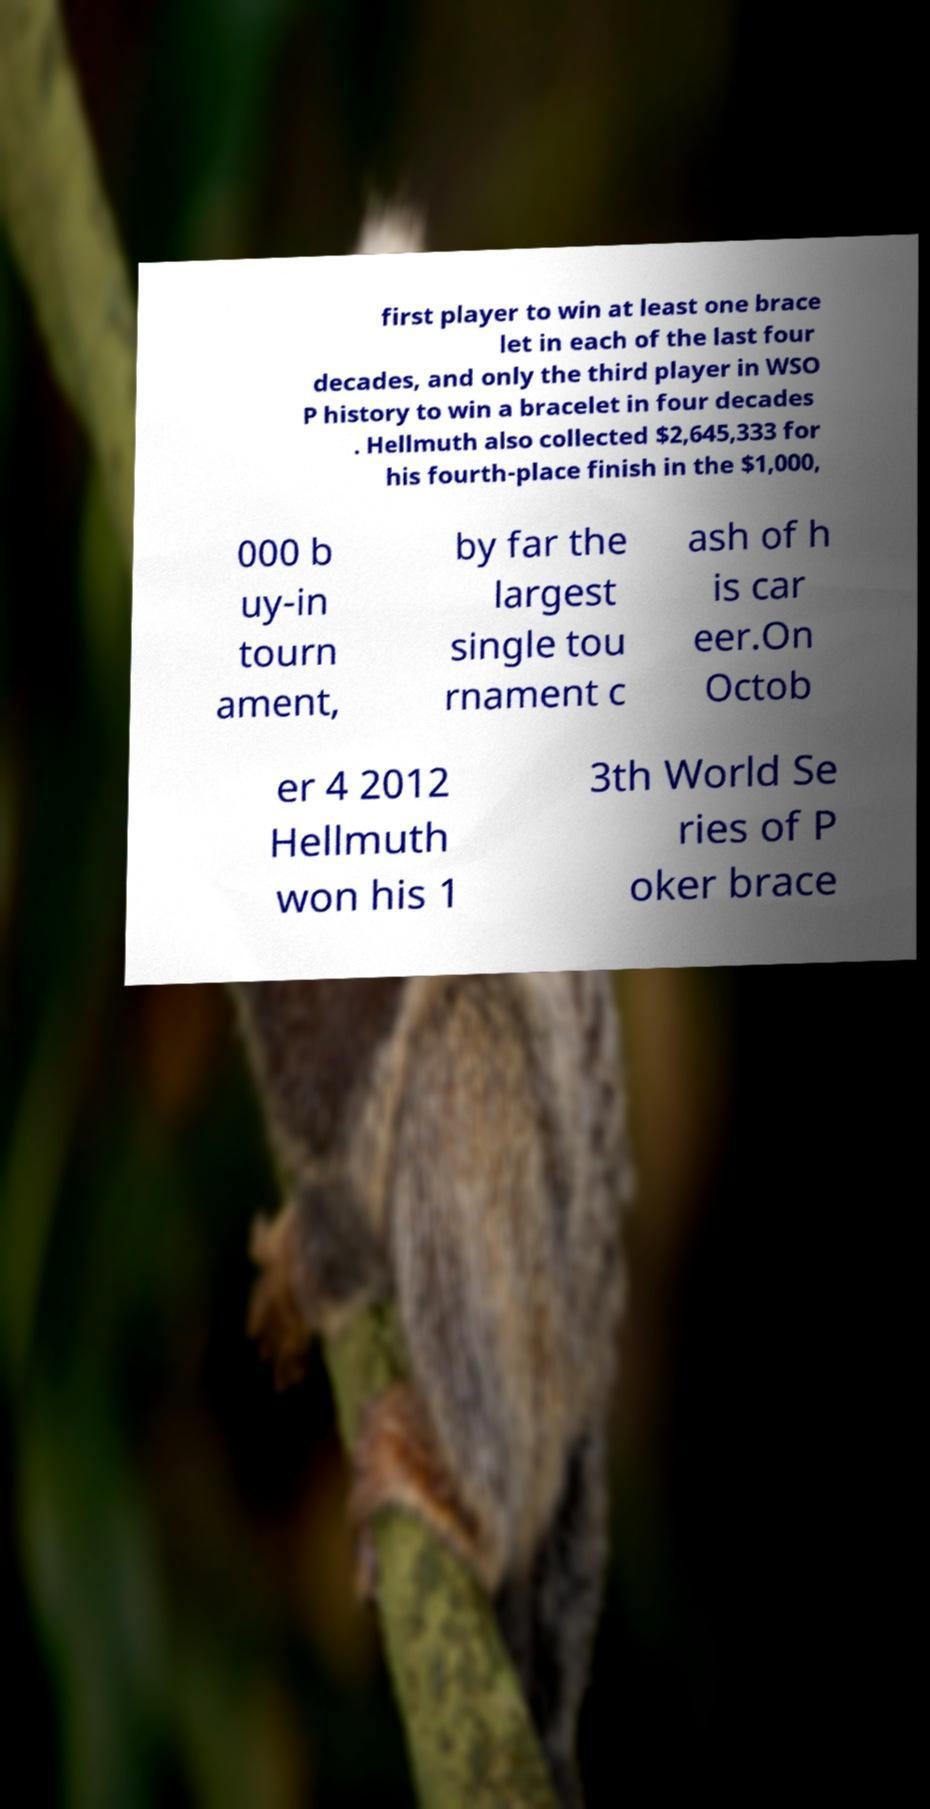There's text embedded in this image that I need extracted. Can you transcribe it verbatim? first player to win at least one brace let in each of the last four decades, and only the third player in WSO P history to win a bracelet in four decades . Hellmuth also collected $2,645,333 for his fourth-place finish in the $1,000, 000 b uy-in tourn ament, by far the largest single tou rnament c ash of h is car eer.On Octob er 4 2012 Hellmuth won his 1 3th World Se ries of P oker brace 